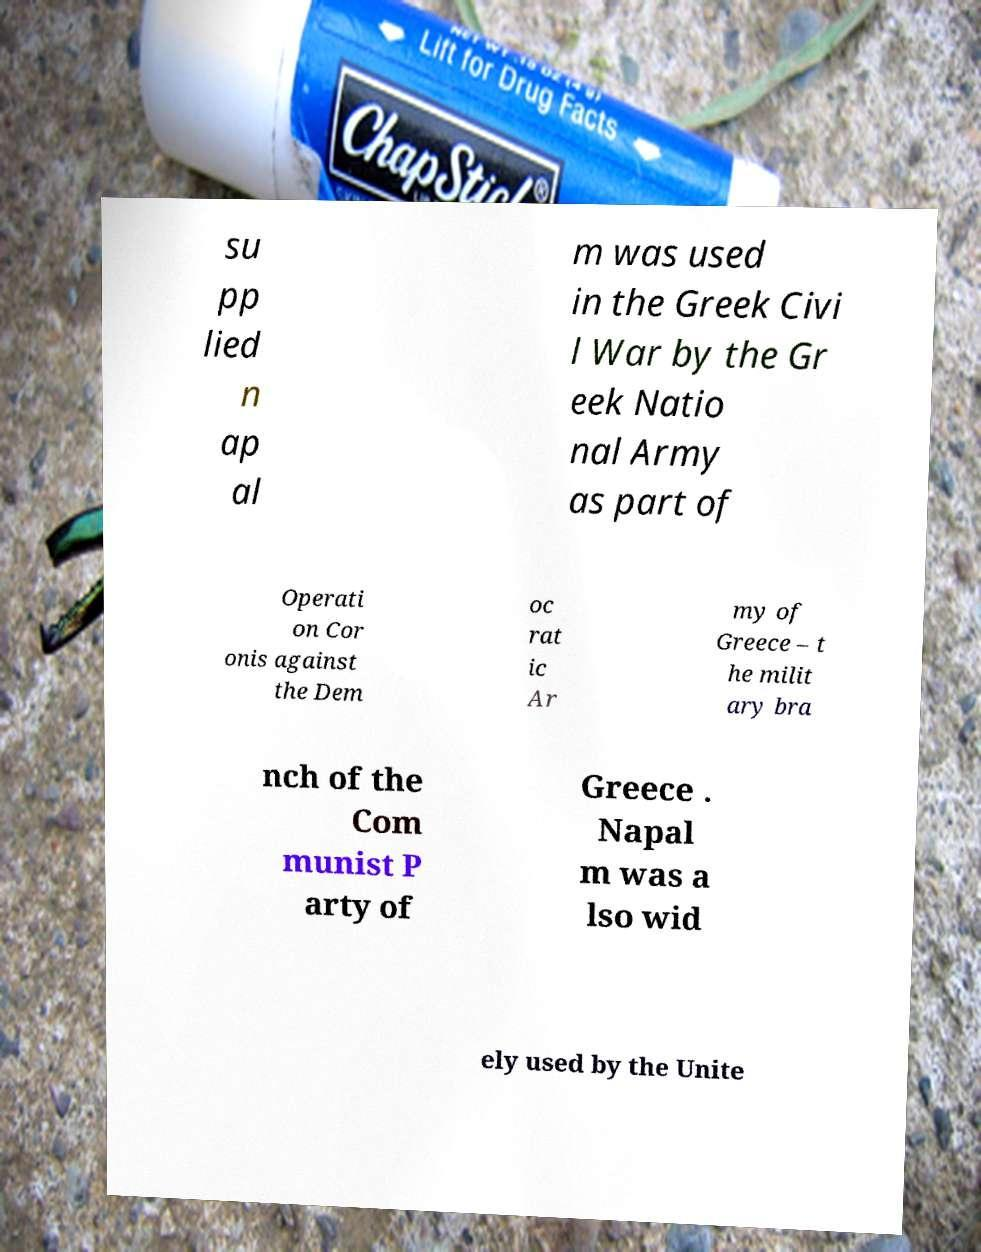For documentation purposes, I need the text within this image transcribed. Could you provide that? su pp lied n ap al m was used in the Greek Civi l War by the Gr eek Natio nal Army as part of Operati on Cor onis against the Dem oc rat ic Ar my of Greece – t he milit ary bra nch of the Com munist P arty of Greece . Napal m was a lso wid ely used by the Unite 